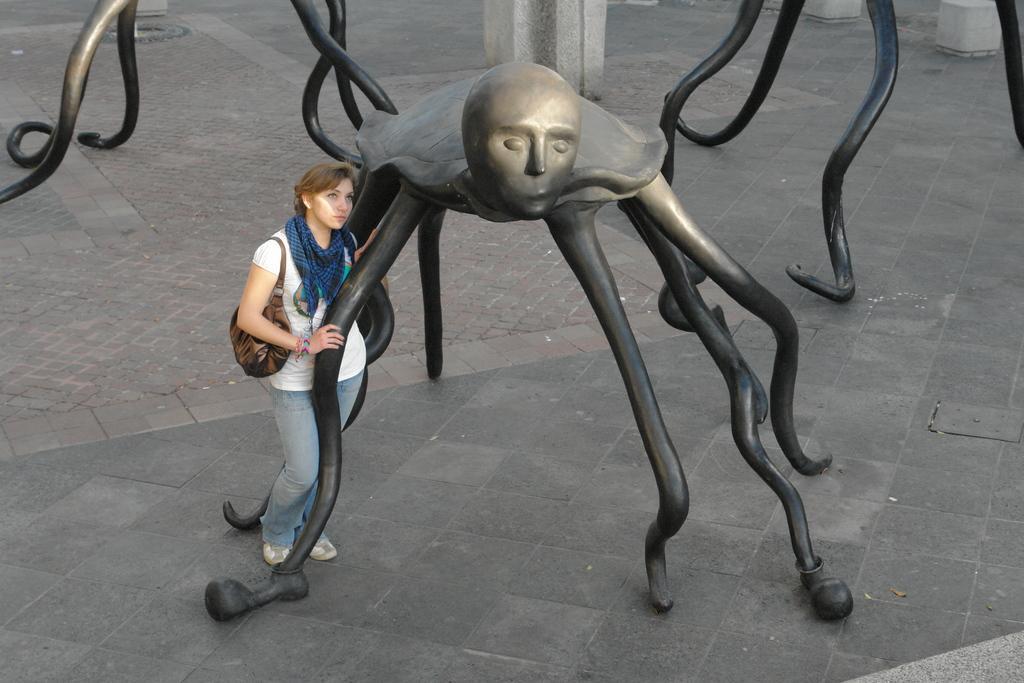How would you summarize this image in a sentence or two? In this image we can see a woman wearing a dress and carrying a bag is standing on the ground holding a statue in her hand. In the background, we can see some metal rods and some pillars. 